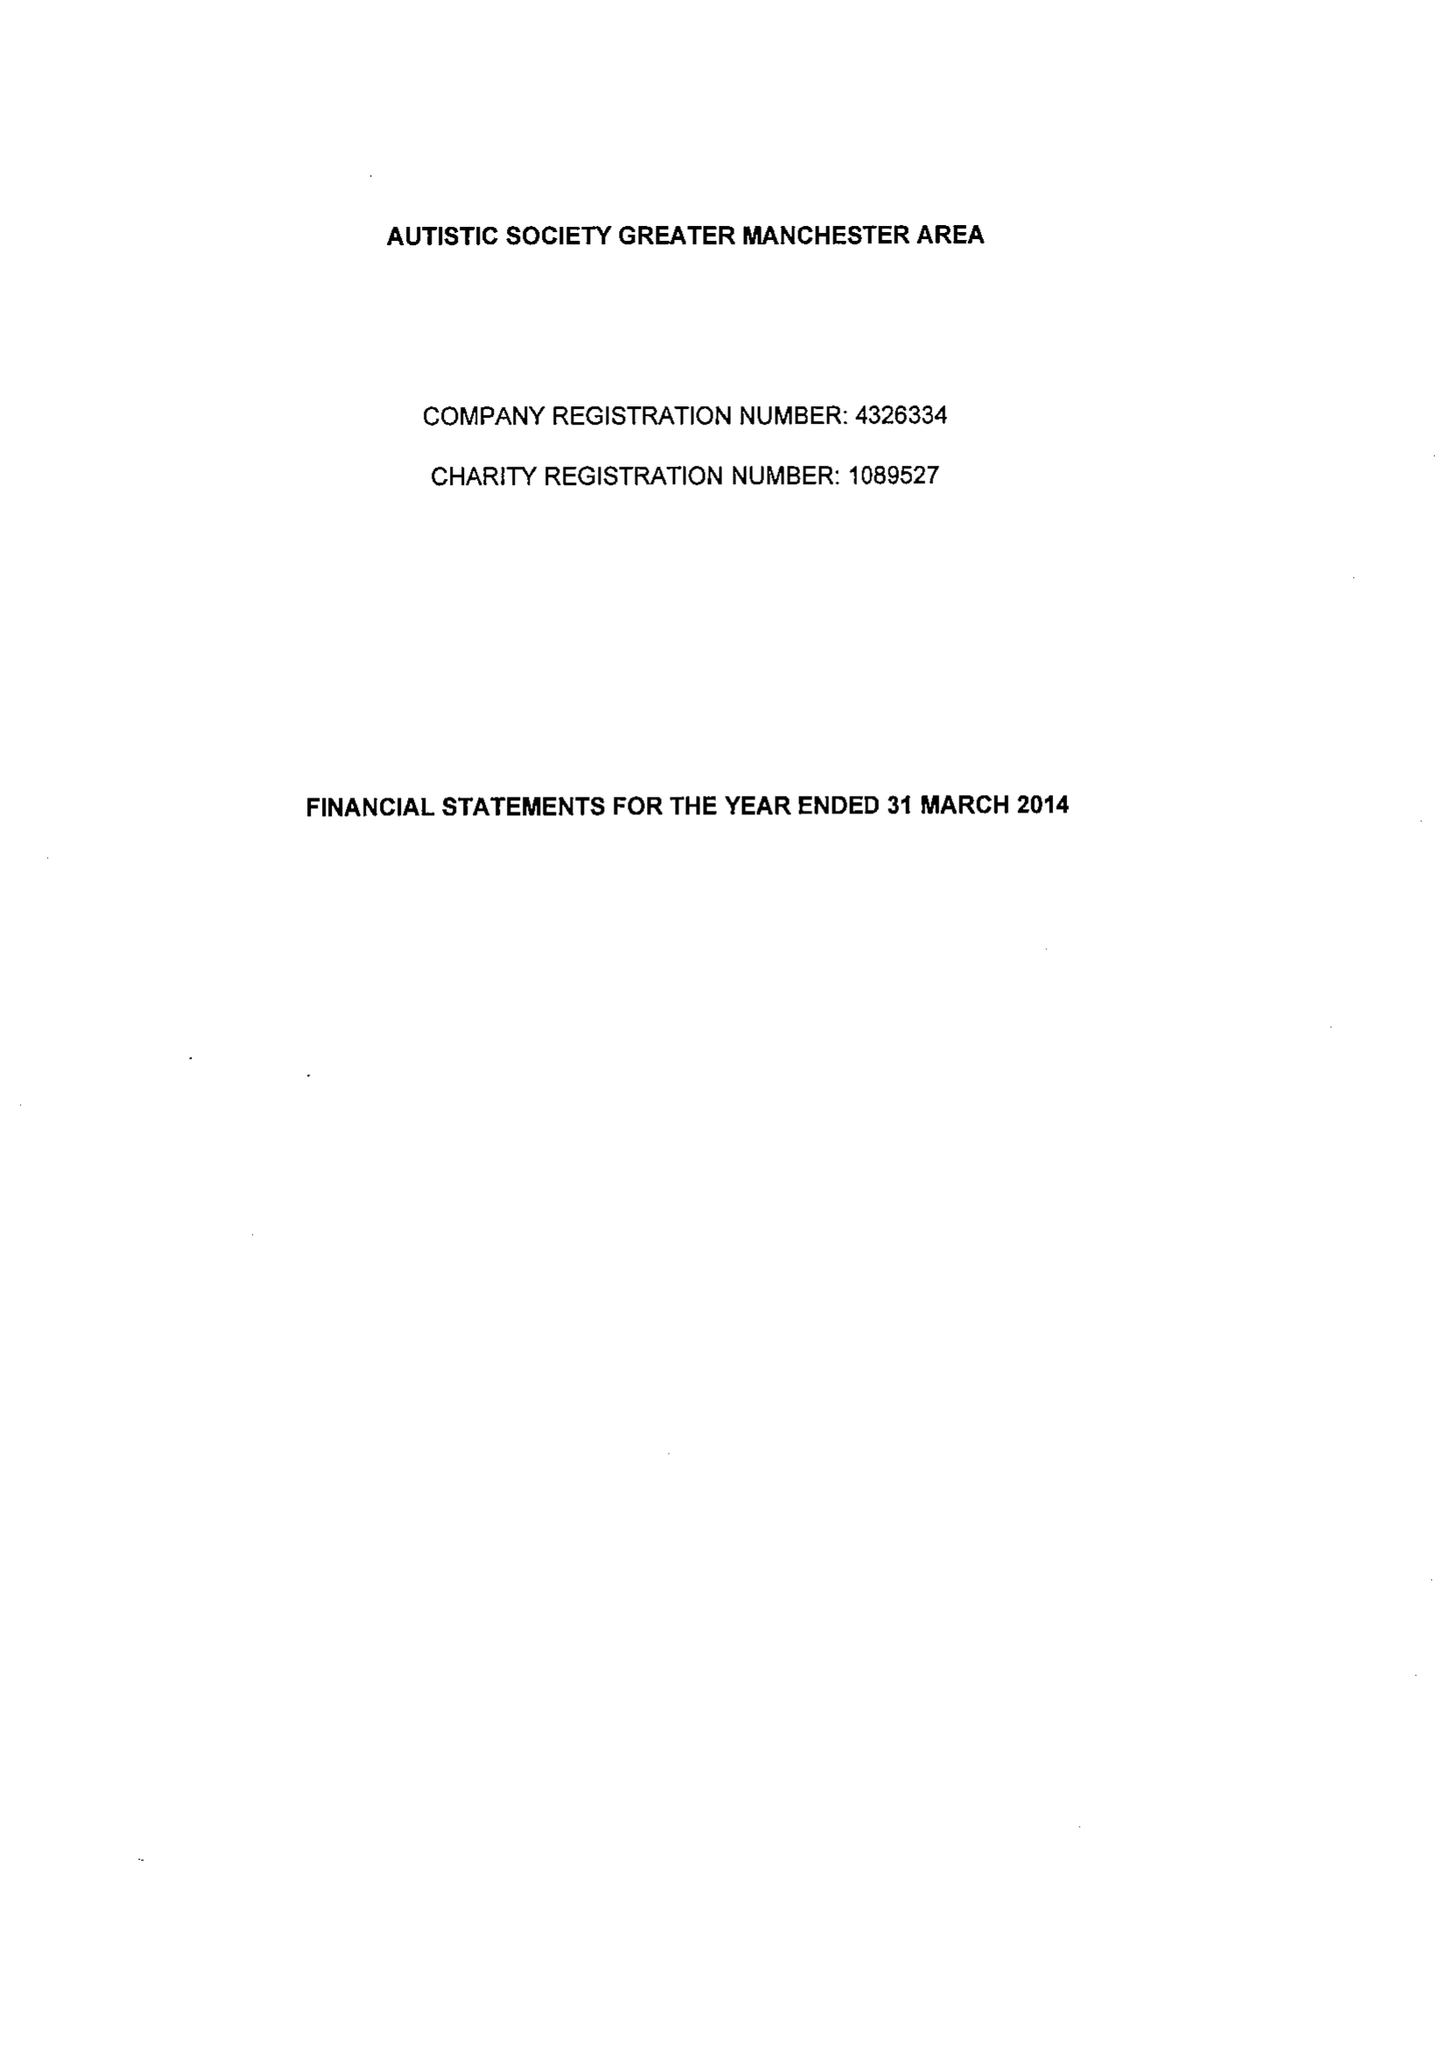What is the value for the address__postcode?
Answer the question using a single word or phrase. M32 0HL 